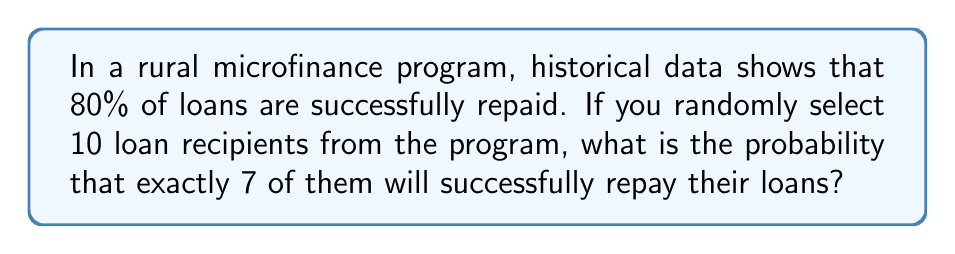Provide a solution to this math problem. To solve this problem, we'll use the binomial probability formula, as we're dealing with a fixed number of independent trials (selecting 10 loan recipients) with two possible outcomes for each (repay or not repay).

1. Let's define our variables:
   $n = 10$ (number of loan recipients)
   $k = 7$ (number of successful repayments we're interested in)
   $p = 0.8$ (probability of successful repayment)
   $q = 1 - p = 0.2$ (probability of unsuccessful repayment)

2. The binomial probability formula is:

   $$P(X = k) = \binom{n}{k} p^k q^{n-k}$$

3. Calculate the binomial coefficient:
   $$\binom{10}{7} = \frac{10!}{7!(10-7)!} = \frac{10!}{7!3!} = 120$$

4. Now, let's substitute all values into the formula:

   $$P(X = 7) = 120 \cdot (0.8)^7 \cdot (0.2)^{10-7}$$
   
   $$= 120 \cdot (0.8)^7 \cdot (0.2)^3$$

5. Calculate the result:
   $$= 120 \cdot 0.2097152 \cdot 0.008$$
   $$= 0.201126912$$

6. Round to 4 decimal places:
   $$\approx 0.2011$$

Therefore, the probability of exactly 7 out of 10 randomly selected loan recipients successfully repaying their loans is approximately 0.2011 or 20.11%.
Answer: $0.2011$ 